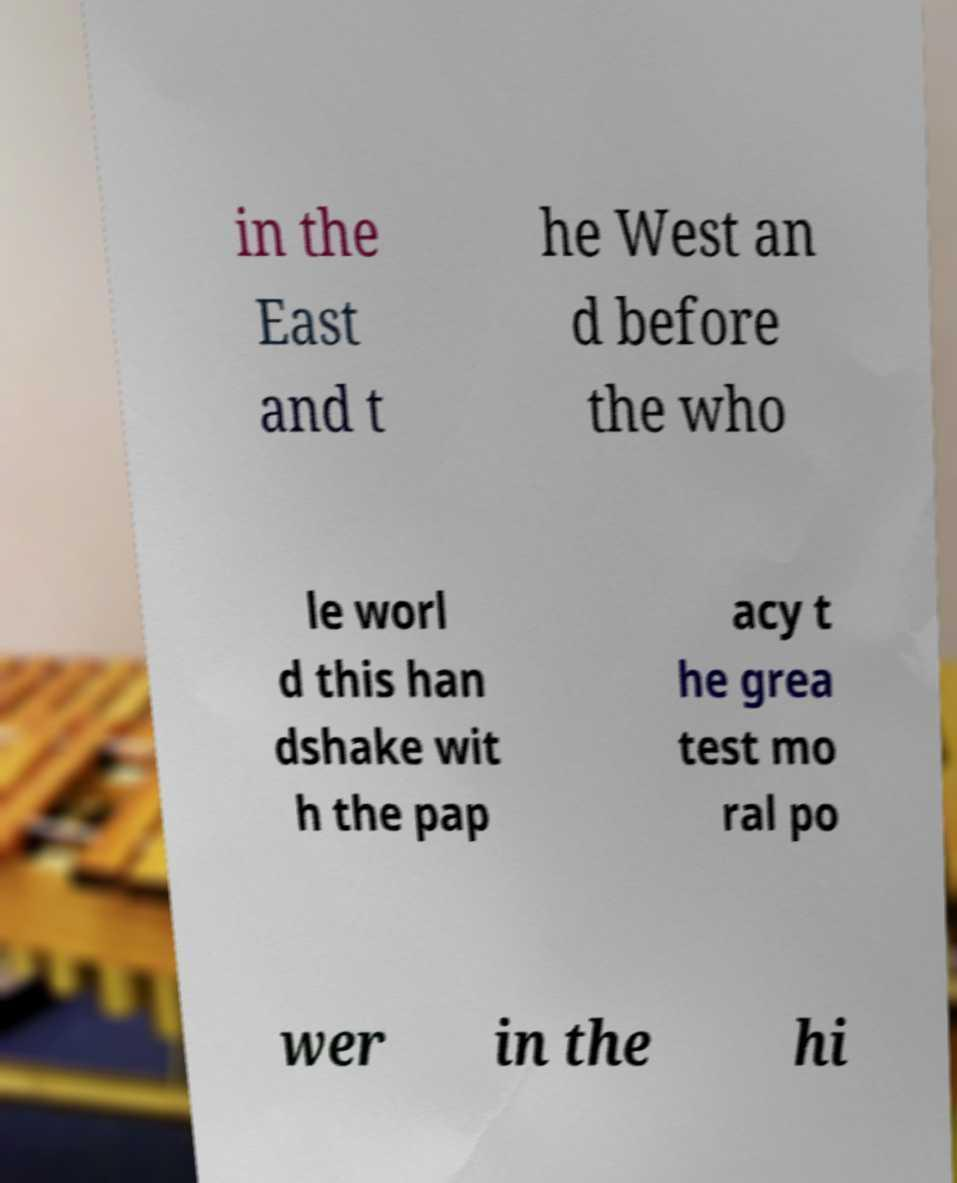Could you extract and type out the text from this image? in the East and t he West an d before the who le worl d this han dshake wit h the pap acy t he grea test mo ral po wer in the hi 